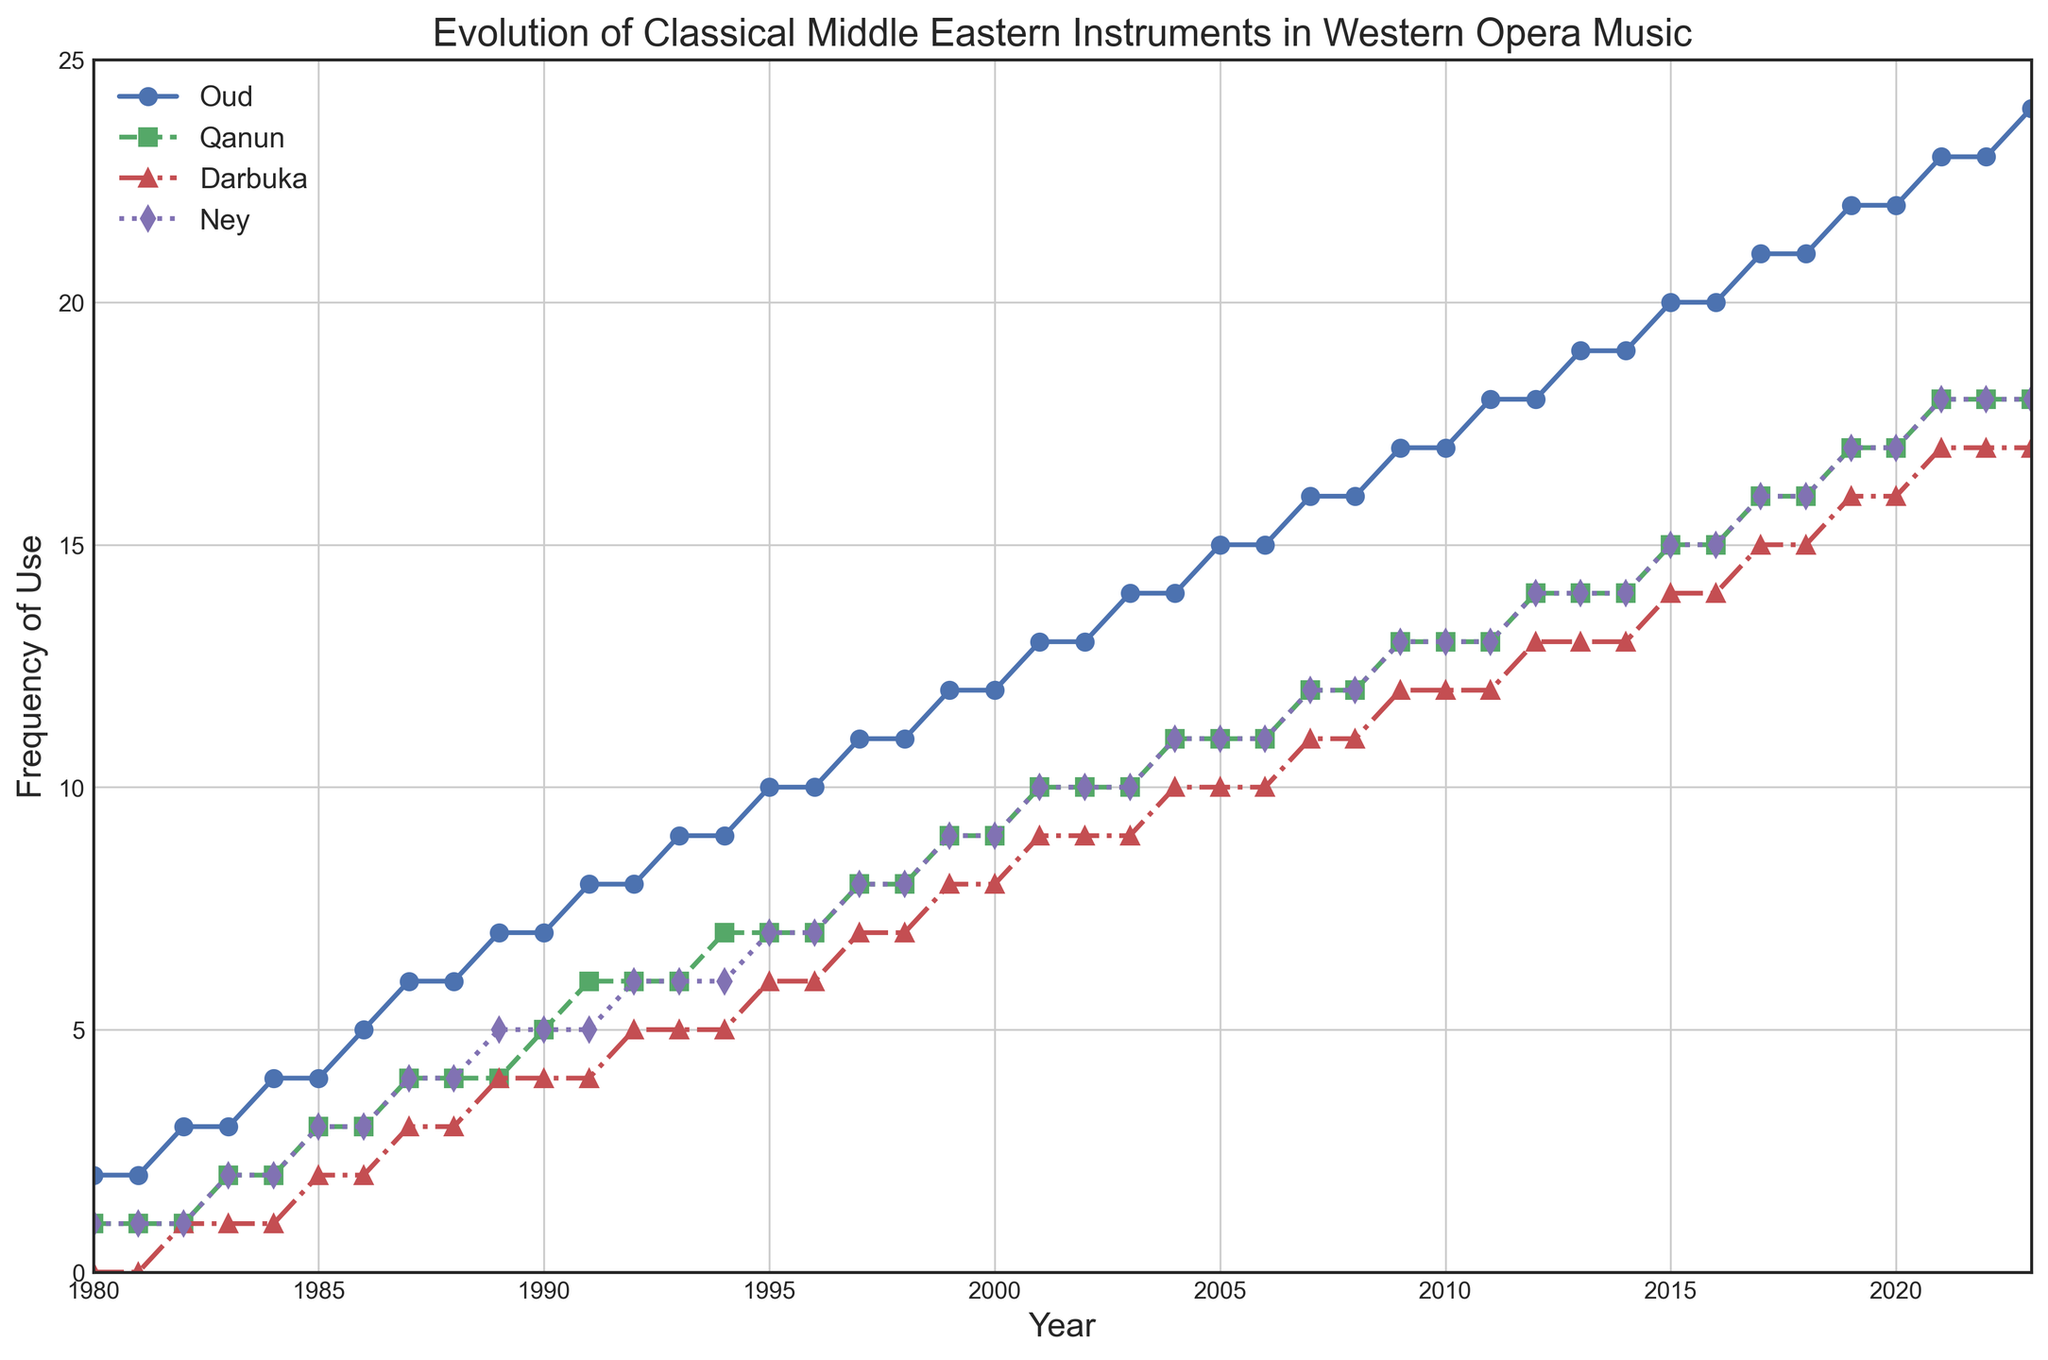What's the overall trend in the frequency of use of the oud instrument from 1980 to 2023? By looking at the line for the oud, it's clear that the frequency of use has shown a steady increase over the years. The line consistently rises from 1980 (~2 uses) to 2023 (~24 uses).
Answer: Increasing Between 1983 and 1987, which instrument showed the most significant increase in usage? To determine this, compare the change in frequency for each instrument between 1983 and 1987. The oud increased from 3 to 6, the qanun from 2 to 4, the darbuka from 1 to 3, and the ney from 2 to 4. The oud and ney both show an increase of 3, but the darbuka has a greater relative increase, moving from 1 to 3 (200% increase).
Answer: Darbuka How does the frequency of use of the ney compare to the qanun in 2023? In 2023, the ney is used 18 times while the qanun is used 18 times. Both have the same frequency of use in that year.
Answer: Equal Which instrument had the least variation in its frequency of use over the entire period? To determine this, evaluate how much the frequency changes for each instrument from start to end. The darbuka starts at 0 and ends at 17, the ney starts at 1 and ends at 18, the qanun starts at 1 and ends at 18, and the oud starts at 2 and ends at 24. The darbuka has the least change comparatively.
Answer: Darbuka By how much did the frequency of use of the qanun increase from 1995 to 2005? In 1995, the qanun's frequency of use was 7, and in 2005, it was 11. The increase is calculated as 11 - 7 = 4.
Answer: 4 Between 2000 and 2010, which instrument had the highest average frequency of use? Calculate the average frequency of each instrument over these years (2000-2010 inclusive). Oud: (12+13+14+14+15+15+16+16+17+17+18)/11 = ~15.45. Qanun: (9+10+10+11+11+11+12+12+13+13+13)/11 = ~11.36. Darbuka: (8+9+9+10+10+10+11+11+12+12+12)/11 = ~10.18. Ney: (9+10+10+11+11+11+12+12+13+13+13)/11 = ~11.36. Therefore, oud has the highest average frequency of use.
Answer: Oud In which year did all instruments show the same frequency of use, if any? By inspecting the figure, there are no years where all instrument frequencies are equal.
Answer: None What is the combined frequency of use of all instruments in the year 2015? Add the frequencies for each instrument in 2015: oud (20), qanun (15), darbuka (14), ney (15). The sum is 20 + 15 + 14 + 15 = 64.
Answer: 64 Which instrument showed the highest frequency of use in the year 1990? For 1990, the usage frequencies are: oud (7), qanun (5), darbuka (4), ney (5). The highest frequency is for the oud.
Answer: Oud What is the percentage increase in frequency of the ney from 1980 to 2023? The frequency of the ney in 1980 is 1 and in 2023 is 18. The percentage increase is calculated as ((18 - 1) / 1) * 100 = 1700%.
Answer: 1700% 